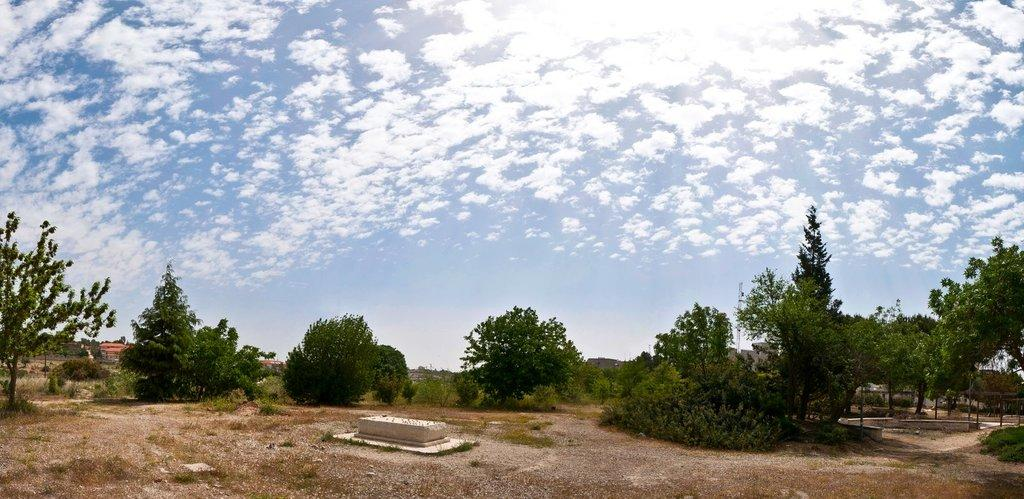What type of vegetation can be seen in the image? There are trees in the image. What is located on the ground in the image? There is a stone on the ground in the image. What can be seen in the background of the image? The sky is visible in the background of the image. What is present in the sky? Clouds are present in the sky. What thrill can be experienced by the group of clouds in the image? There is no group of clouds in the image, and therefore no thrill can be experienced. What afterthought is present in the image? There is no afterthought present in the image; it only features trees, a stone, the sky, and clouds. 